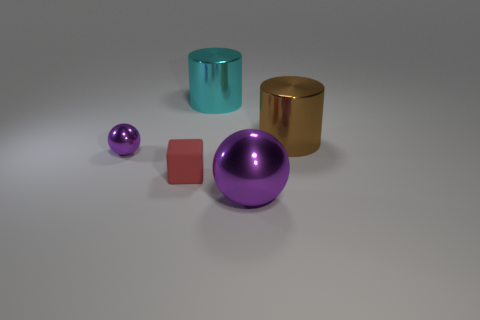Add 2 big blue rubber blocks. How many objects exist? 7 Subtract all blocks. How many objects are left? 4 Subtract all tiny cyan metal blocks. Subtract all purple metallic things. How many objects are left? 3 Add 1 metallic cylinders. How many metallic cylinders are left? 3 Add 4 metallic cylinders. How many metallic cylinders exist? 6 Subtract 0 green spheres. How many objects are left? 5 